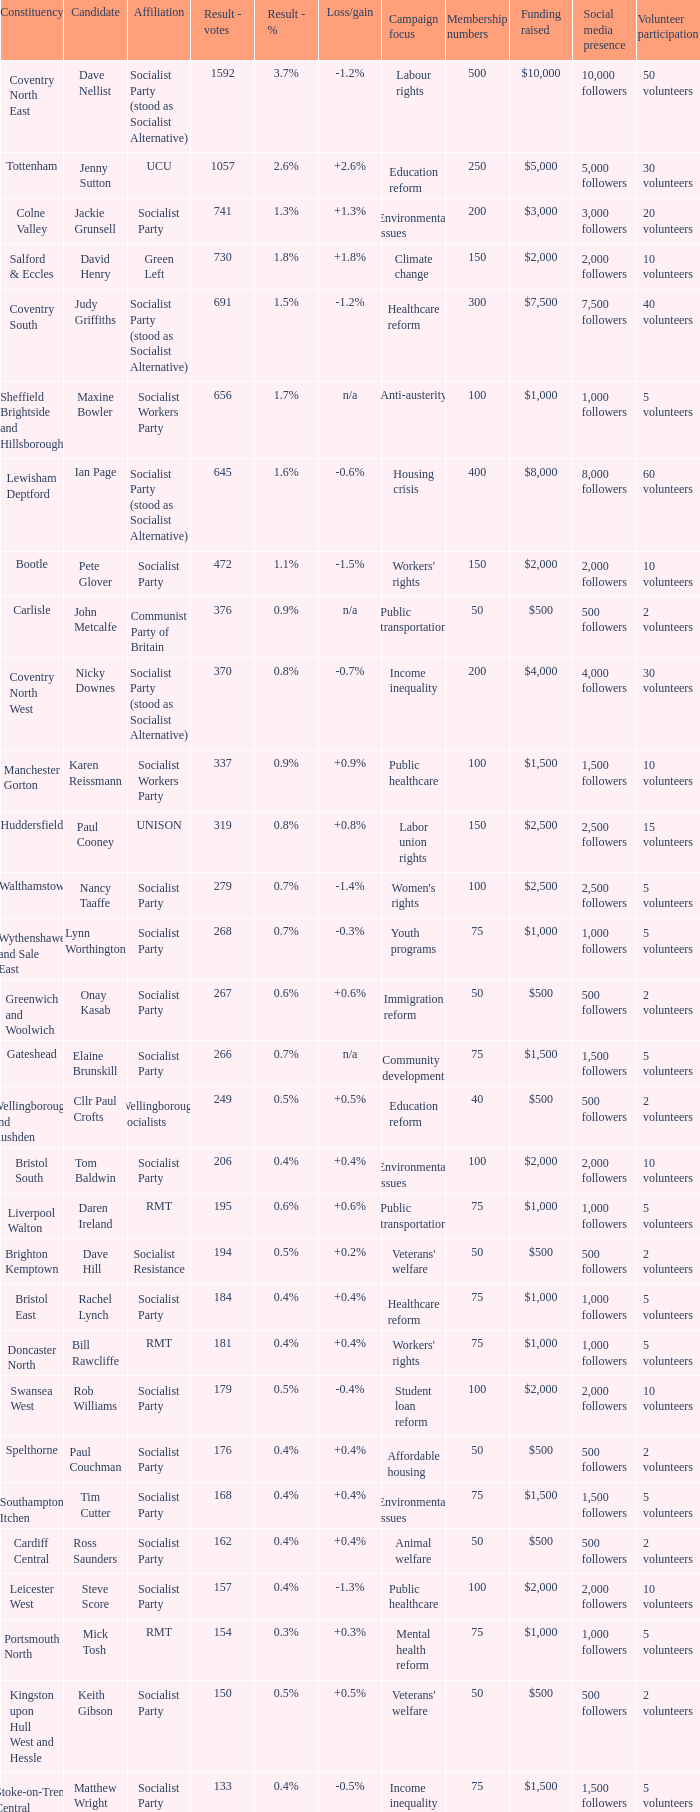Which candidates are participating in the election for the cardiff central constituency? Ross Saunders. Help me parse the entirety of this table. {'header': ['Constituency', 'Candidate', 'Affiliation', 'Result - votes', 'Result - %', 'Loss/gain', 'Campaign focus', 'Membership numbers', 'Funding raised', 'Social media presence', 'Volunteer participation'], 'rows': [['Coventry North East', 'Dave Nellist', 'Socialist Party (stood as Socialist Alternative)', '1592', '3.7%', '-1.2%', 'Labour rights', '500', '$10,000', '10,000 followers', '50 volunteers'], ['Tottenham', 'Jenny Sutton', 'UCU', '1057', '2.6%', '+2.6%', 'Education reform', '250', '$5,000', '5,000 followers', '30 volunteers'], ['Colne Valley', 'Jackie Grunsell', 'Socialist Party', '741', '1.3%', '+1.3%', 'Environmental issues', '200', '$3,000', '3,000 followers', '20 volunteers'], ['Salford & Eccles', 'David Henry', 'Green Left', '730', '1.8%', '+1.8%', 'Climate change', '150', '$2,000', '2,000 followers', '10 volunteers'], ['Coventry South', 'Judy Griffiths', 'Socialist Party (stood as Socialist Alternative)', '691', '1.5%', '-1.2%', 'Healthcare reform', '300', '$7,500', '7,500 followers', '40 volunteers'], ['Sheffield Brightside and Hillsborough', 'Maxine Bowler', 'Socialist Workers Party', '656', '1.7%', 'n/a', 'Anti-austerity', '100', '$1,000', '1,000 followers', '5 volunteers'], ['Lewisham Deptford', 'Ian Page', 'Socialist Party (stood as Socialist Alternative)', '645', '1.6%', '-0.6%', 'Housing crisis', '400', '$8,000', '8,000 followers', '60 volunteers'], ['Bootle', 'Pete Glover', 'Socialist Party', '472', '1.1%', '-1.5%', "Workers' rights", '150', '$2,000', '2,000 followers', '10 volunteers'], ['Carlisle', 'John Metcalfe', 'Communist Party of Britain', '376', '0.9%', 'n/a', 'Public transportation', '50', '$500', '500 followers', '2 volunteers'], ['Coventry North West', 'Nicky Downes', 'Socialist Party (stood as Socialist Alternative)', '370', '0.8%', '-0.7%', 'Income inequality', '200', '$4,000', '4,000 followers', '30 volunteers'], ['Manchester Gorton', 'Karen Reissmann', 'Socialist Workers Party', '337', '0.9%', '+0.9%', 'Public healthcare', '100', '$1,500', '1,500 followers', '10 volunteers'], ['Huddersfield', 'Paul Cooney', 'UNISON', '319', '0.8%', '+0.8%', 'Labor union rights', '150', '$2,500', '2,500 followers', '15 volunteers'], ['Walthamstow', 'Nancy Taaffe', 'Socialist Party', '279', '0.7%', '-1.4%', "Women's rights", '100', '$2,500', '2,500 followers', '5 volunteers'], ['Wythenshawe and Sale East', 'Lynn Worthington', 'Socialist Party', '268', '0.7%', '-0.3%', 'Youth programs', '75', '$1,000', '1,000 followers', '5 volunteers'], ['Greenwich and Woolwich', 'Onay Kasab', 'Socialist Party', '267', '0.6%', '+0.6%', 'Immigration reform', '50', '$500', '500 followers', '2 volunteers'], ['Gateshead', 'Elaine Brunskill', 'Socialist Party', '266', '0.7%', 'n/a', 'Community development', '75', '$1,500', '1,500 followers', '5 volunteers'], ['Wellingborough and Rushden', 'Cllr Paul Crofts', 'Wellingborough Socialists', '249', '0.5%', '+0.5%', 'Education reform', '40', '$500', '500 followers', '2 volunteers'], ['Bristol South', 'Tom Baldwin', 'Socialist Party', '206', '0.4%', '+0.4%', 'Environmental issues', '100', '$2,000', '2,000 followers', '10 volunteers'], ['Liverpool Walton', 'Daren Ireland', 'RMT', '195', '0.6%', '+0.6%', 'Public transportation', '75', '$1,000', '1,000 followers', '5 volunteers'], ['Brighton Kemptown', 'Dave Hill', 'Socialist Resistance', '194', '0.5%', '+0.2%', "Veterans' welfare", '50', '$500', '500 followers', '2 volunteers'], ['Bristol East', 'Rachel Lynch', 'Socialist Party', '184', '0.4%', '+0.4%', 'Healthcare reform', '75', '$1,000', '1,000 followers', '5 volunteers'], ['Doncaster North', 'Bill Rawcliffe', 'RMT', '181', '0.4%', '+0.4%', "Workers' rights", '75', '$1,000', '1,000 followers', '5 volunteers'], ['Swansea West', 'Rob Williams', 'Socialist Party', '179', '0.5%', '-0.4%', 'Student loan reform', '100', '$2,000', '2,000 followers', '10 volunteers'], ['Spelthorne', 'Paul Couchman', 'Socialist Party', '176', '0.4%', '+0.4%', 'Affordable housing', '50', '$500', '500 followers', '2 volunteers'], ['Southampton Itchen', 'Tim Cutter', 'Socialist Party', '168', '0.4%', '+0.4%', 'Environmental issues', '75', '$1,500', '1,500 followers', '5 volunteers'], ['Cardiff Central', 'Ross Saunders', 'Socialist Party', '162', '0.4%', '+0.4%', 'Animal welfare', '50', '$500', '500 followers', '2 volunteers'], ['Leicester West', 'Steve Score', 'Socialist Party', '157', '0.4%', '-1.3%', 'Public healthcare', '100', '$2,000', '2,000 followers', '10 volunteers'], ['Portsmouth North', 'Mick Tosh', 'RMT', '154', '0.3%', '+0.3%', 'Mental health reform', '75', '$1,000', '1,000 followers', '5 volunteers'], ['Kingston upon Hull West and Hessle', 'Keith Gibson', 'Socialist Party', '150', '0.5%', '+0.5%', "Veterans' welfare", '50', '$500', '500 followers', '2 volunteers'], ['Stoke-on-Trent Central', 'Matthew Wright', 'Socialist Party', '133', '0.4%', '-0.5%', 'Income inequality', '75', '$1,500', '1,500 followers', '5 volunteers']]} 